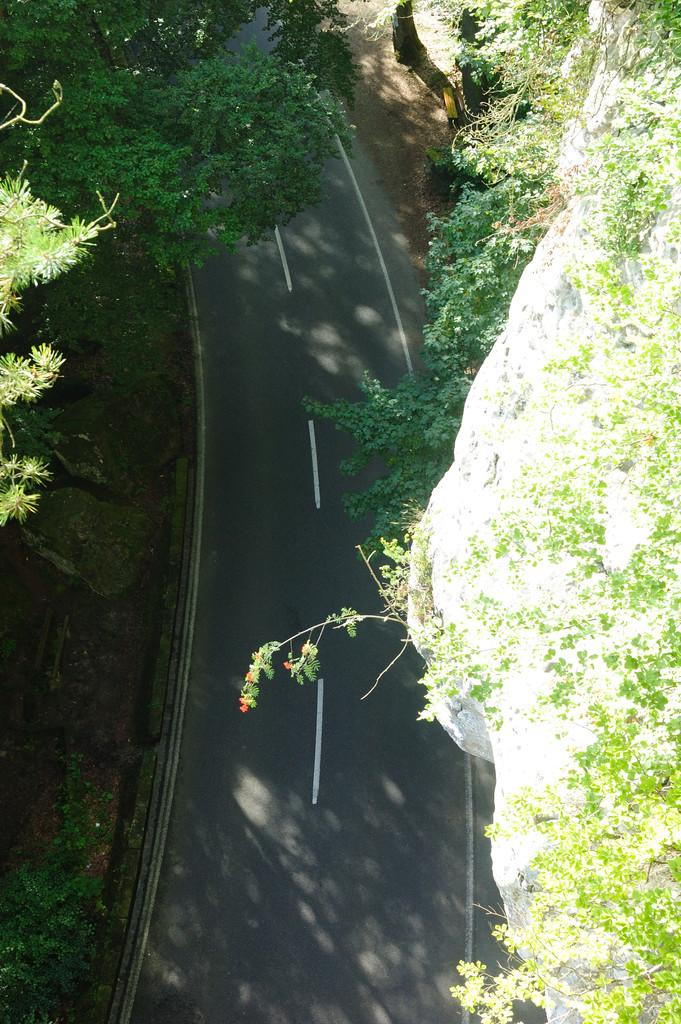What type of vegetation can be seen in the image? There are trees in the image. What color is the hair of the tree in the image? Trees do not have hair, so this question is not applicable to the image. 